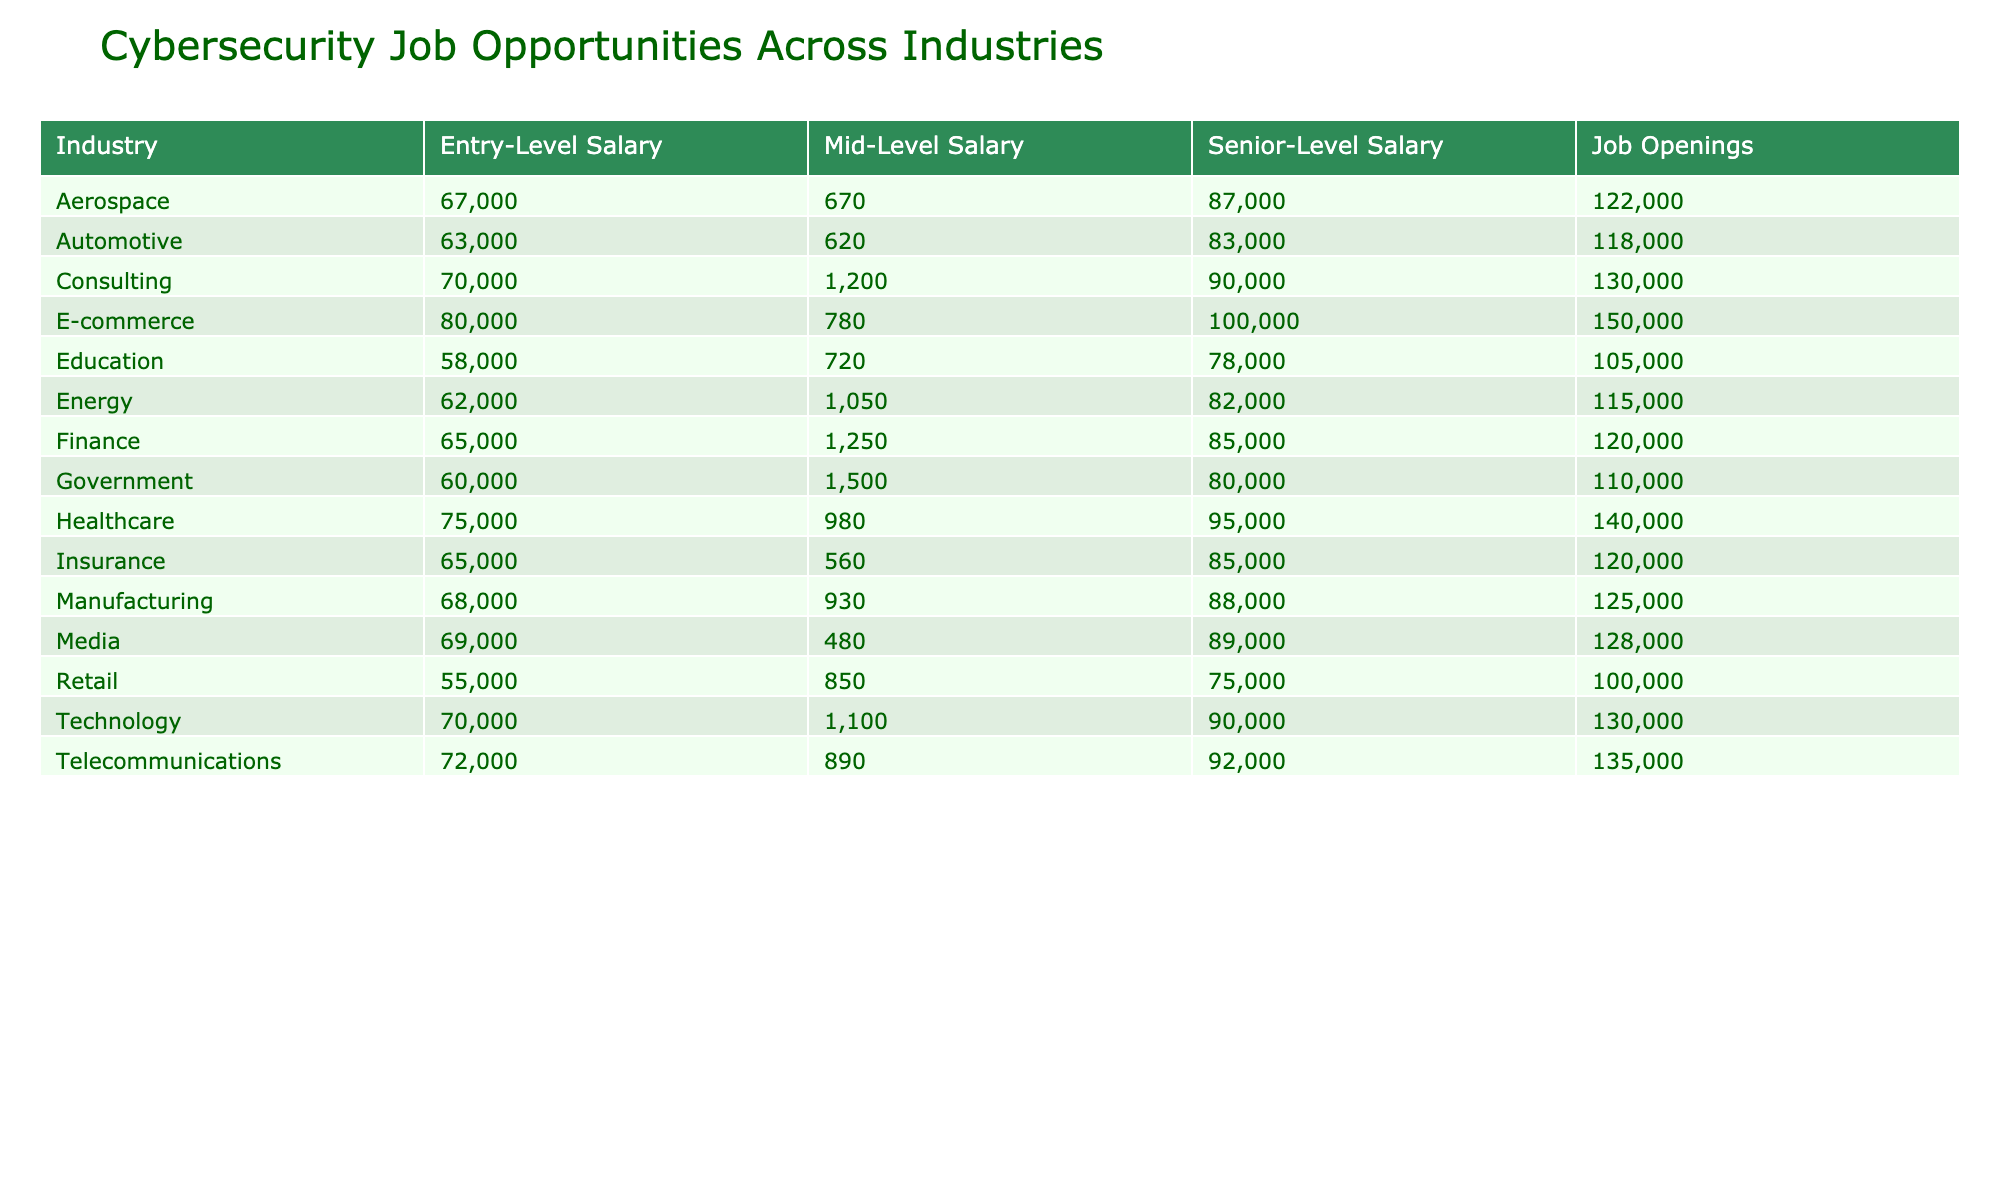What is the highest senior-level salary across the industries? The highest senior-level salary listed is 150000, which is for the position of Cloud Security Architect in the E-commerce industry.
Answer: 150000 Which industry has the most job openings in cybersecurity? The Government industry has the most job openings, totaling 1500 openings.
Answer: Government What is the average entry-level salary for the Technology and Healthcare industries combined? For Technology, the entry-level salary is 70000, and for Healthcare, it is 75000. Summing these gives 70000 + 75000 = 145000. Since there are two industries, the average is 145000 / 2 = 72500.
Answer: 72500 Is it true that the Retail industry has a higher mid-level salary than the Automotive industry? The Retail mid-level salary is 75000, and the Automotive mid-level salary is 83000. Since 75000 is less than 83000, the statement is false.
Answer: No Which industry has the lowest work-life balance rating? The Technology industry has the lowest work-life balance rating of 5 out of 10.
Answer: Technology How much higher is the mid-level salary for a Cybersecurity Specialist compared to an IT Security Coordinator? The mid-level salary for a Cybersecurity Specialist is 80000, and for an IT Security Coordinator, it is 75000. The difference is 80000 - 75000 = 5000, indicating that the Cybersecurity Specialist earns 5000 more.
Answer: 5000 If you were looking for the top three industries with the highest mid-level salaries, which would they be? The top three industries with the highest mid-level salaries are E-commerce (100000), Healthcare (95000), and Technology (90000).
Answer: E-commerce, Healthcare, Technology What percentage of job openings are available in the Finance sector compared to the total job openings across all industries? The total job openings across all industries add up to 1050 + 1500 + 980 + 1100 + 850 + 720 + 930 + 1050 + 890 + 780 + 670 + 1200 + 560 + 480 + 620 = 12330. The Finance sector has 1250 job openings. Thus, the percentage is (1250 / 12330) * 100 ≈ 10.12%.
Answer: 10.12% 